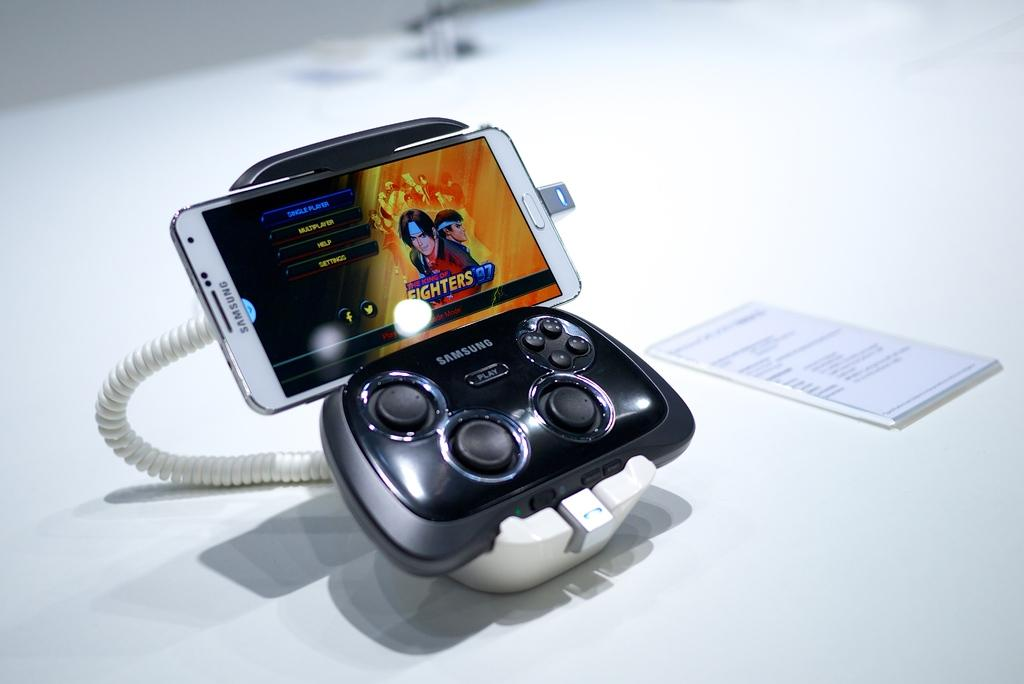<image>
Render a clear and concise summary of the photo. A samsung phoen hooked up to a controller with a fighting game on it. 